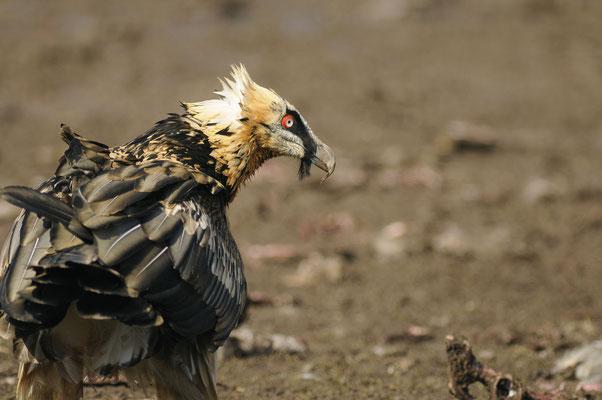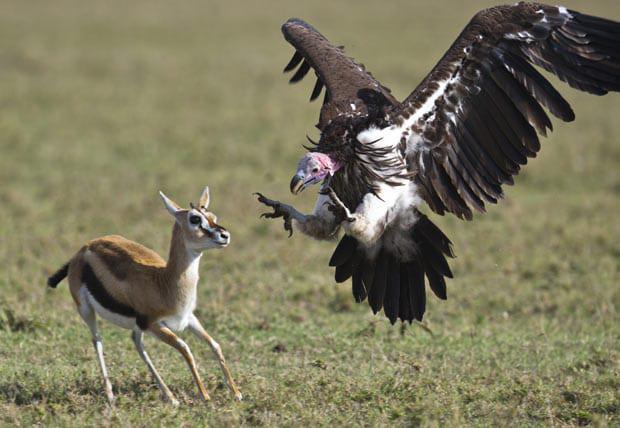The first image is the image on the left, the second image is the image on the right. Evaluate the accuracy of this statement regarding the images: "A vulture is face-to-face with a jackal standing in profile on all fours, in one image.". Is it true? Answer yes or no. No. 